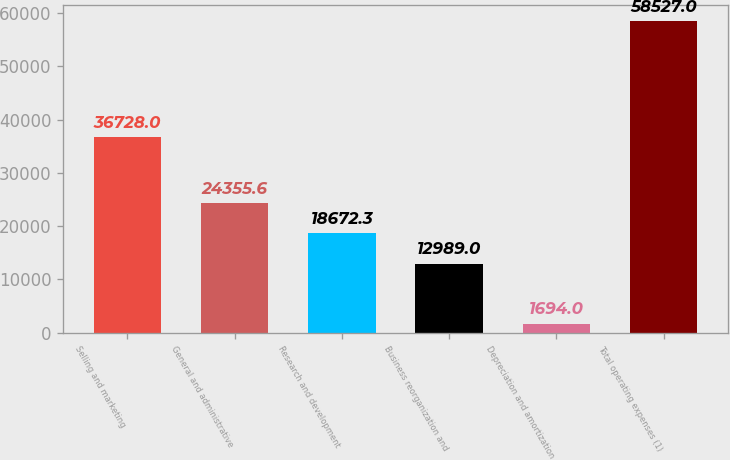Convert chart. <chart><loc_0><loc_0><loc_500><loc_500><bar_chart><fcel>Selling and marketing<fcel>General and administrative<fcel>Research and development<fcel>Business reorganization and<fcel>Depreciation and amortization<fcel>Total operating expenses (1)<nl><fcel>36728<fcel>24355.6<fcel>18672.3<fcel>12989<fcel>1694<fcel>58527<nl></chart> 